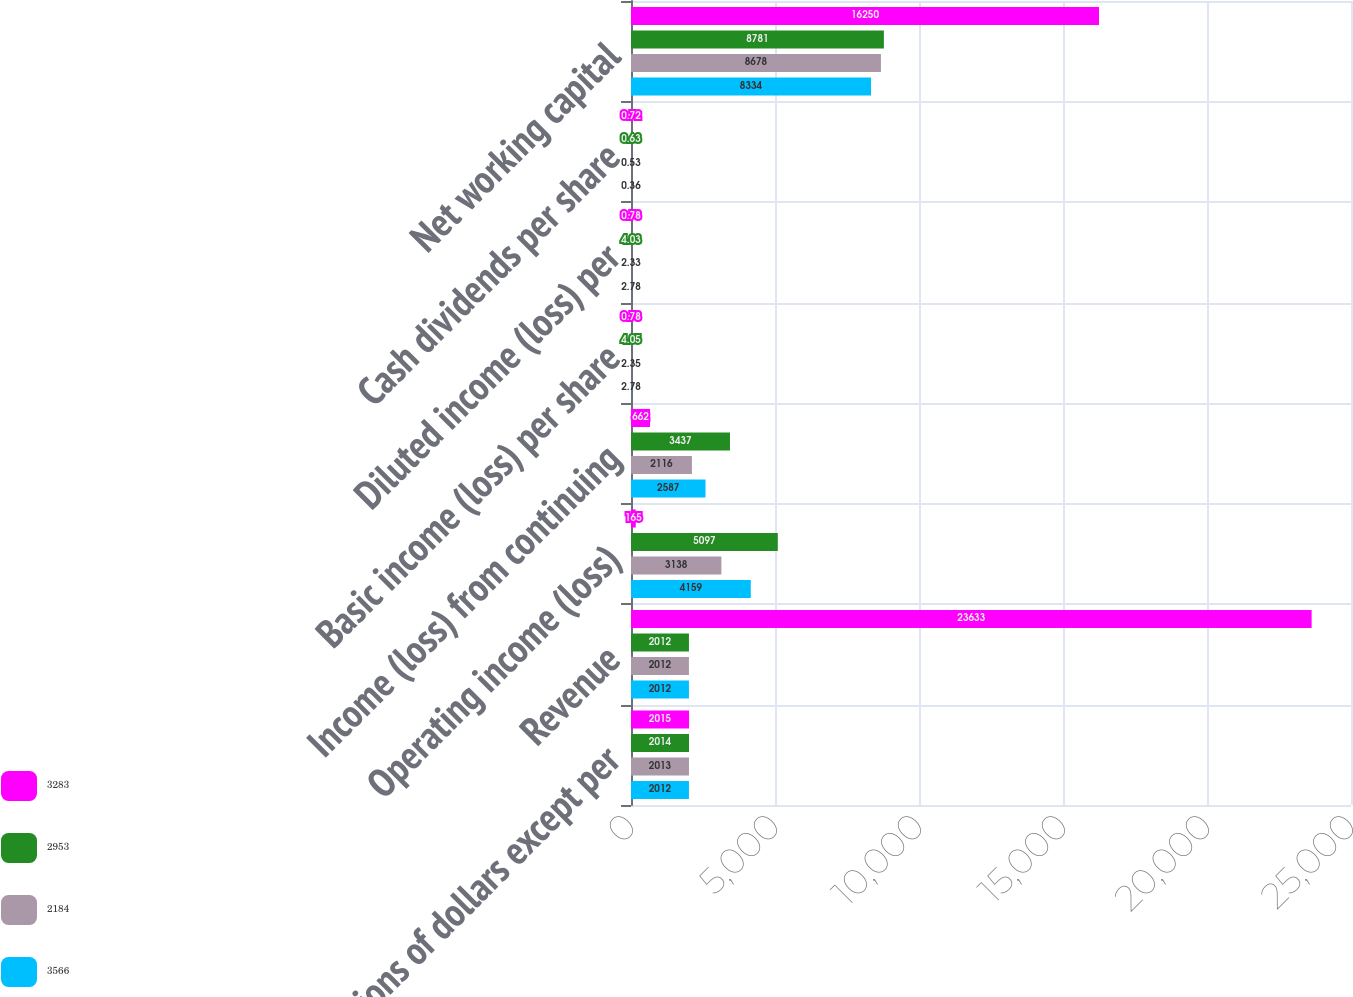Convert chart to OTSL. <chart><loc_0><loc_0><loc_500><loc_500><stacked_bar_chart><ecel><fcel>Millions of dollars except per<fcel>Revenue<fcel>Operating income (loss)<fcel>Income (loss) from continuing<fcel>Basic income (loss) per share<fcel>Diluted income (loss) per<fcel>Cash dividends per share<fcel>Net working capital<nl><fcel>3283<fcel>2015<fcel>23633<fcel>165<fcel>662<fcel>0.78<fcel>0.78<fcel>0.72<fcel>16250<nl><fcel>2953<fcel>2014<fcel>2012<fcel>5097<fcel>3437<fcel>4.05<fcel>4.03<fcel>0.63<fcel>8781<nl><fcel>2184<fcel>2013<fcel>2012<fcel>3138<fcel>2116<fcel>2.35<fcel>2.33<fcel>0.53<fcel>8678<nl><fcel>3566<fcel>2012<fcel>2012<fcel>4159<fcel>2587<fcel>2.78<fcel>2.78<fcel>0.36<fcel>8334<nl></chart> 